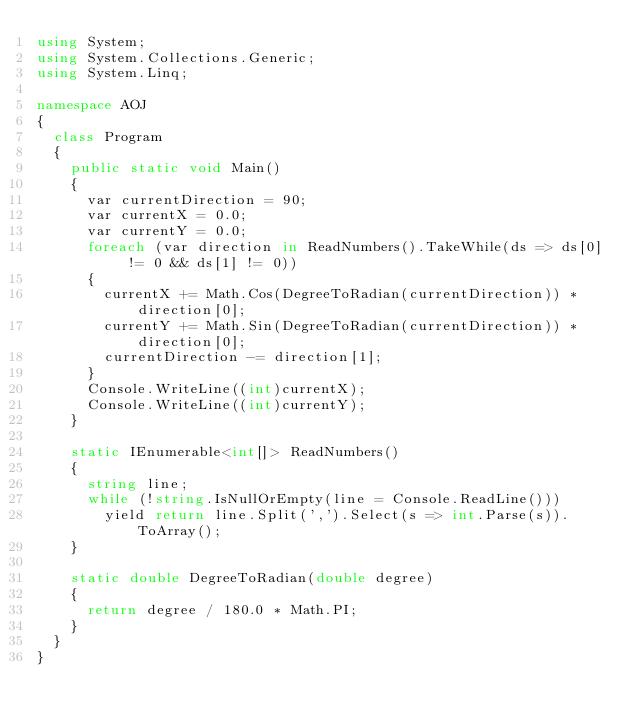Convert code to text. <code><loc_0><loc_0><loc_500><loc_500><_C#_>using System;
using System.Collections.Generic;
using System.Linq;

namespace AOJ
{
  class Program
  {
    public static void Main()
    {
      var currentDirection = 90;
      var currentX = 0.0;
      var currentY = 0.0;
      foreach (var direction in ReadNumbers().TakeWhile(ds => ds[0] != 0 && ds[1] != 0))
      {
        currentX += Math.Cos(DegreeToRadian(currentDirection)) * direction[0];
        currentY += Math.Sin(DegreeToRadian(currentDirection)) * direction[0];
        currentDirection -= direction[1];
      }
      Console.WriteLine((int)currentX);
      Console.WriteLine((int)currentY);
    }

    static IEnumerable<int[]> ReadNumbers()
    {
      string line;
      while (!string.IsNullOrEmpty(line = Console.ReadLine()))
        yield return line.Split(',').Select(s => int.Parse(s)).ToArray();
    }

    static double DegreeToRadian(double degree)
    {
      return degree / 180.0 * Math.PI;
    }
  }
}</code> 